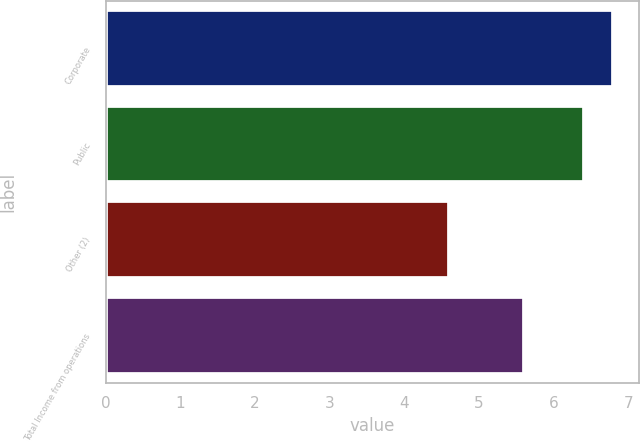<chart> <loc_0><loc_0><loc_500><loc_500><bar_chart><fcel>Corporate<fcel>Public<fcel>Other (2)<fcel>Total Income from operations<nl><fcel>6.8<fcel>6.4<fcel>4.6<fcel>5.6<nl></chart> 